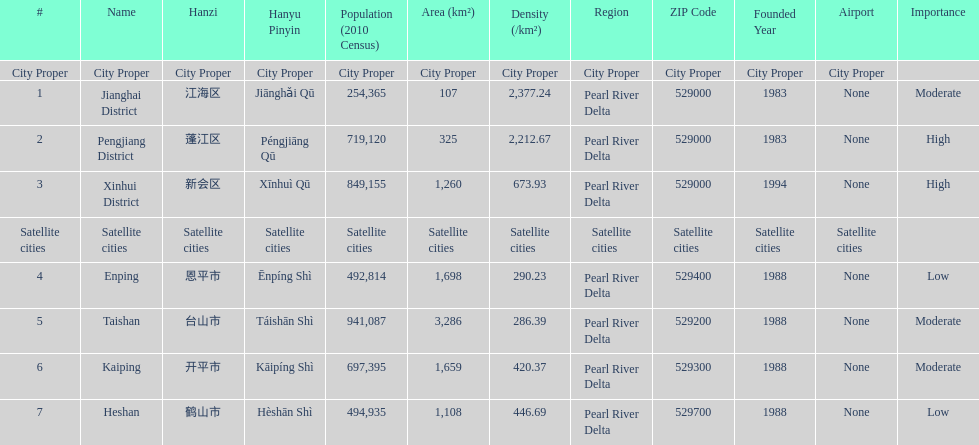Which area is the least dense? Taishan. 